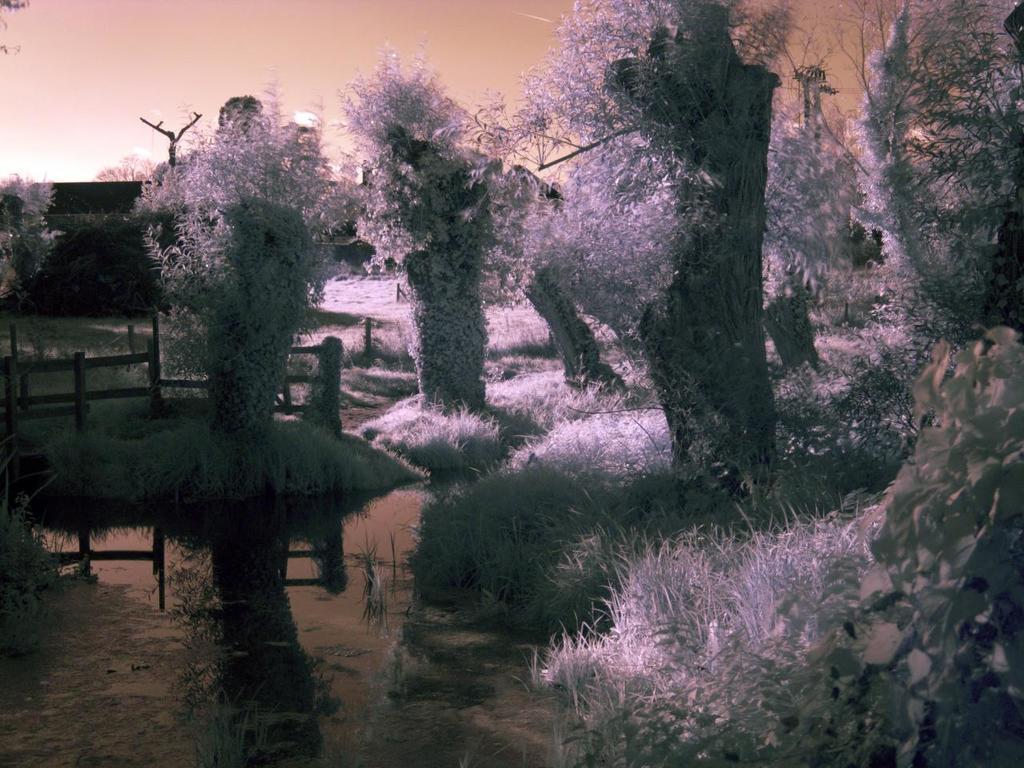In one or two sentences, can you explain what this image depicts? In the picture I can see the water, grass, fence, trees and the sky in the background. 